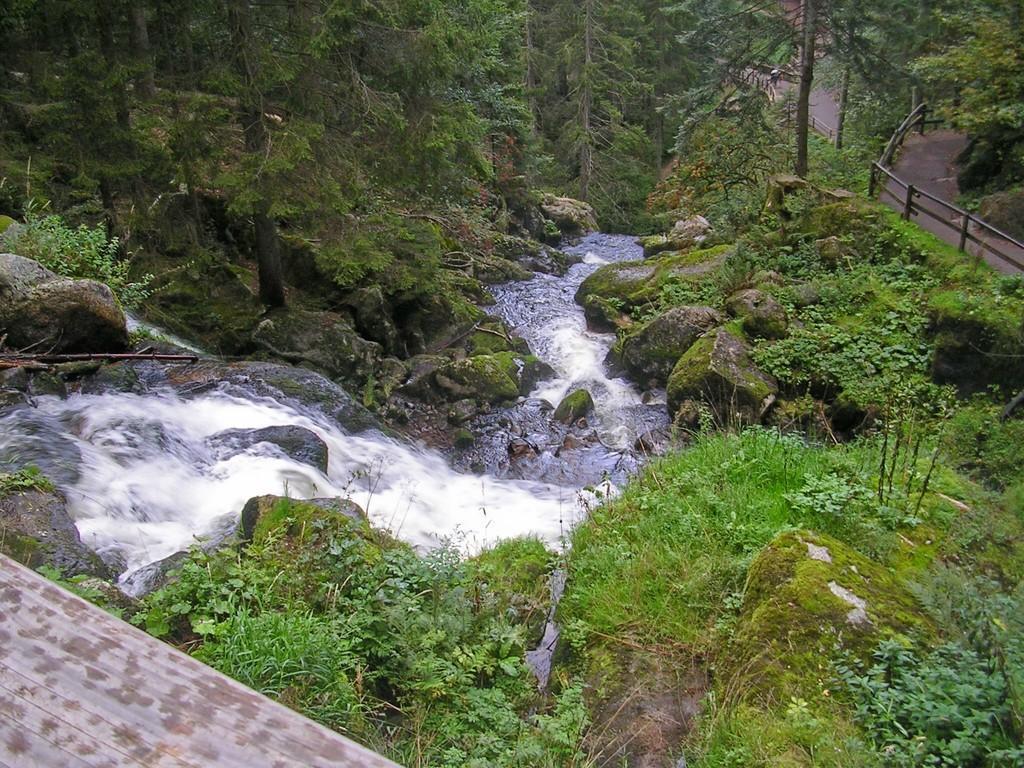In one or two sentences, can you explain what this image depicts? In the image we can see there is waterfall and there are rocks on the ground. The ground is covered with grass and there are trees. There are iron fencing poles on the ground. 